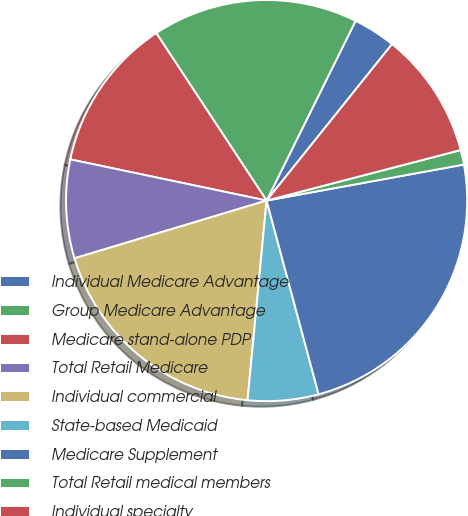<chart> <loc_0><loc_0><loc_500><loc_500><pie_chart><fcel>Individual Medicare Advantage<fcel>Group Medicare Advantage<fcel>Medicare stand-alone PDP<fcel>Total Retail Medicare<fcel>Individual commercial<fcel>State-based Medicaid<fcel>Medicare Supplement<fcel>Total Retail medical members<fcel>Individual specialty<nl><fcel>3.44%<fcel>16.59%<fcel>12.44%<fcel>7.94%<fcel>18.84%<fcel>5.69%<fcel>23.7%<fcel>1.18%<fcel>10.19%<nl></chart> 